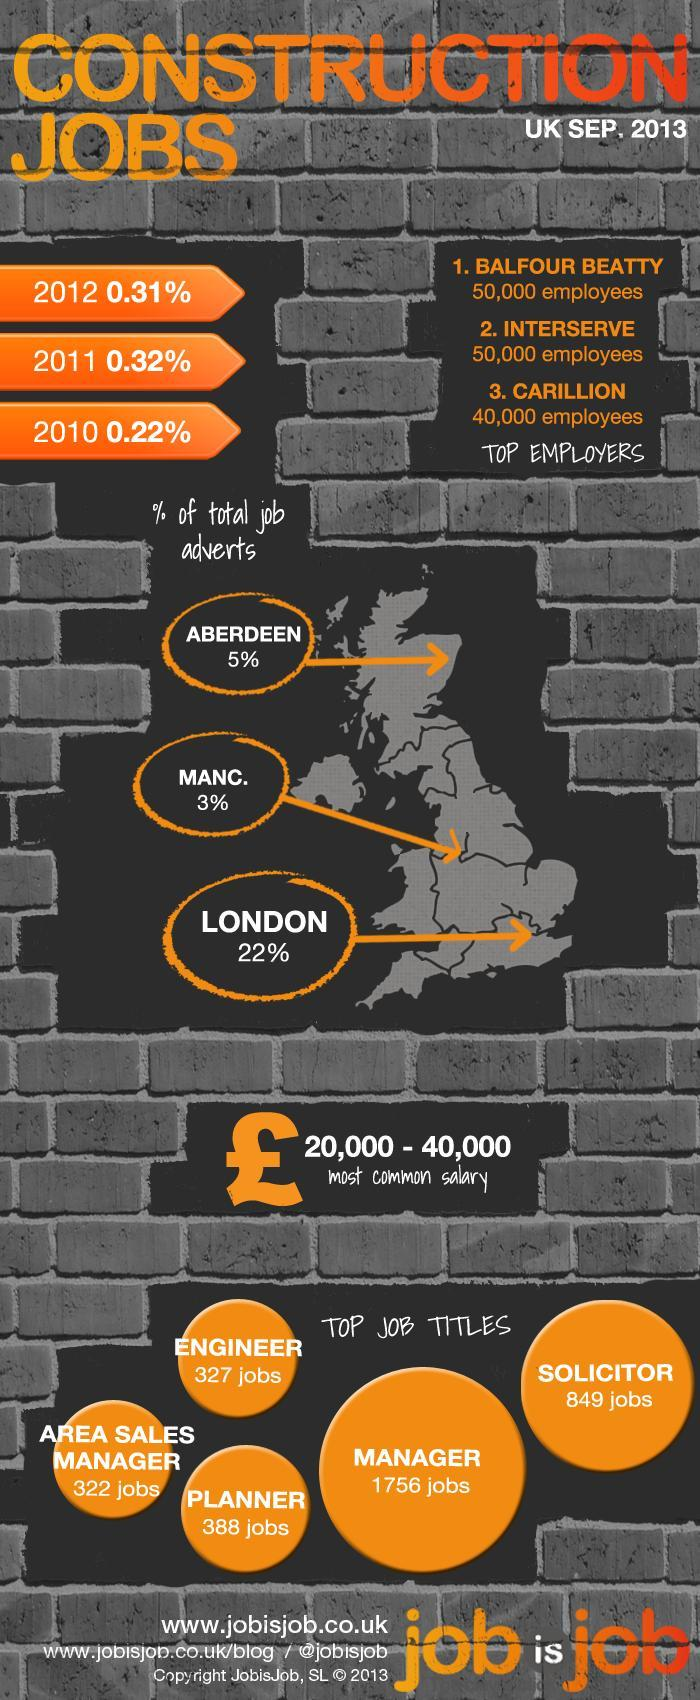For the job title solicitor how many jobs are available in UK?
Answer the question with a short phrase. 849 What is the inverse of the percentage of total job advertisements in London? 78 Which are the top most construction companies in UK? Balfour Beauty, Interserve, Carillion How many Manager positions are open in the construction industry in UK? 1756 Which construction company among the top 3 has least number of employees? Carillion 